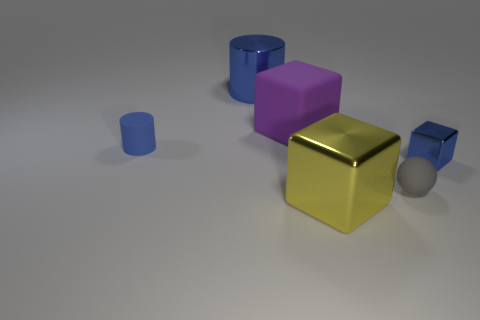How many objects are either large shiny cubes that are in front of the large purple object or blue cylinders that are in front of the big purple cube?
Provide a short and direct response. 2. The blue object that is both to the left of the yellow block and in front of the large blue metal cylinder has what shape?
Offer a terse response. Cylinder. What number of small blue objects are to the right of the tiny blue thing that is to the left of the large purple rubber cube?
Offer a very short reply. 1. How many things are blue things that are on the right side of the small blue cylinder or purple metallic cylinders?
Keep it short and to the point. 2. What is the size of the cylinder on the right side of the tiny blue cylinder?
Provide a short and direct response. Large. What is the small block made of?
Provide a short and direct response. Metal. What is the shape of the blue metallic object that is in front of the metal thing that is behind the blue metal block?
Offer a very short reply. Cube. How many other objects are the same shape as the large purple matte object?
Make the answer very short. 2. There is a tiny matte sphere; are there any tiny blue cubes on the right side of it?
Your answer should be compact. Yes. The large rubber thing has what color?
Your response must be concise. Purple. 